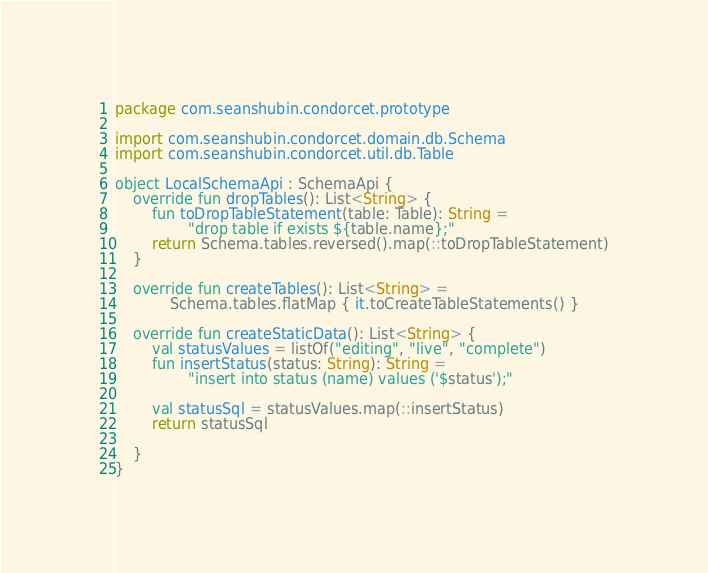<code> <loc_0><loc_0><loc_500><loc_500><_Kotlin_>package com.seanshubin.condorcet.prototype

import com.seanshubin.condorcet.domain.db.Schema
import com.seanshubin.condorcet.util.db.Table

object LocalSchemaApi : SchemaApi {
    override fun dropTables(): List<String> {
        fun toDropTableStatement(table: Table): String =
                "drop table if exists ${table.name};"
        return Schema.tables.reversed().map(::toDropTableStatement)
    }

    override fun createTables(): List<String> =
            Schema.tables.flatMap { it.toCreateTableStatements() }

    override fun createStaticData(): List<String> {
        val statusValues = listOf("editing", "live", "complete")
        fun insertStatus(status: String): String =
                "insert into status (name) values ('$status');"

        val statusSql = statusValues.map(::insertStatus)
        return statusSql

    }
}</code> 